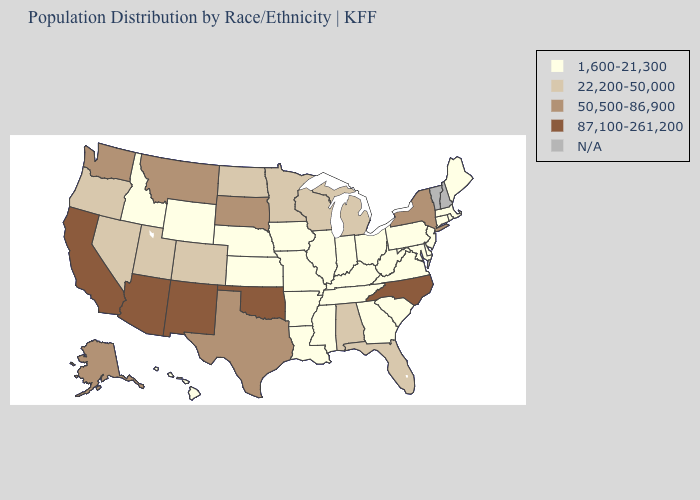What is the lowest value in the USA?
Quick response, please. 1,600-21,300. What is the lowest value in the West?
Keep it brief. 1,600-21,300. Is the legend a continuous bar?
Concise answer only. No. Name the states that have a value in the range N/A?
Answer briefly. New Hampshire, Vermont. Name the states that have a value in the range 87,100-261,200?
Keep it brief. Arizona, California, New Mexico, North Carolina, Oklahoma. Does the map have missing data?
Write a very short answer. Yes. What is the lowest value in the Northeast?
Short answer required. 1,600-21,300. What is the lowest value in the West?
Short answer required. 1,600-21,300. What is the highest value in states that border Missouri?
Be succinct. 87,100-261,200. Among the states that border Ohio , which have the lowest value?
Quick response, please. Indiana, Kentucky, Pennsylvania, West Virginia. Name the states that have a value in the range 1,600-21,300?
Concise answer only. Arkansas, Connecticut, Delaware, Georgia, Hawaii, Idaho, Illinois, Indiana, Iowa, Kansas, Kentucky, Louisiana, Maine, Maryland, Massachusetts, Mississippi, Missouri, Nebraska, New Jersey, Ohio, Pennsylvania, Rhode Island, South Carolina, Tennessee, Virginia, West Virginia, Wyoming. What is the value of South Dakota?
Write a very short answer. 50,500-86,900. What is the value of Texas?
Keep it brief. 50,500-86,900. Name the states that have a value in the range 87,100-261,200?
Short answer required. Arizona, California, New Mexico, North Carolina, Oklahoma. 